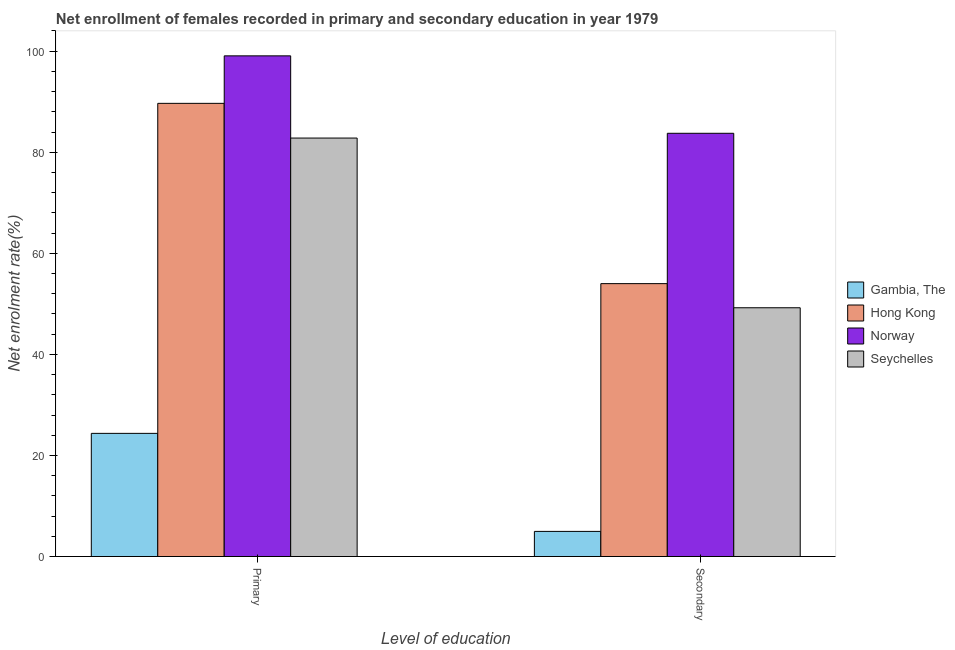How many groups of bars are there?
Make the answer very short. 2. Are the number of bars on each tick of the X-axis equal?
Offer a very short reply. Yes. How many bars are there on the 2nd tick from the left?
Provide a short and direct response. 4. What is the label of the 2nd group of bars from the left?
Offer a very short reply. Secondary. What is the enrollment rate in primary education in Hong Kong?
Keep it short and to the point. 89.68. Across all countries, what is the maximum enrollment rate in secondary education?
Offer a terse response. 83.75. Across all countries, what is the minimum enrollment rate in primary education?
Make the answer very short. 24.37. In which country was the enrollment rate in secondary education maximum?
Offer a very short reply. Norway. In which country was the enrollment rate in primary education minimum?
Offer a terse response. Gambia, The. What is the total enrollment rate in primary education in the graph?
Your answer should be very brief. 295.93. What is the difference between the enrollment rate in primary education in Hong Kong and that in Norway?
Offer a terse response. -9.4. What is the difference between the enrollment rate in secondary education in Hong Kong and the enrollment rate in primary education in Norway?
Provide a succinct answer. -45.07. What is the average enrollment rate in secondary education per country?
Provide a succinct answer. 47.99. What is the difference between the enrollment rate in primary education and enrollment rate in secondary education in Seychelles?
Your response must be concise. 33.58. What is the ratio of the enrollment rate in primary education in Norway to that in Seychelles?
Keep it short and to the point. 1.2. Is the enrollment rate in secondary education in Seychelles less than that in Norway?
Offer a terse response. Yes. In how many countries, is the enrollment rate in primary education greater than the average enrollment rate in primary education taken over all countries?
Your answer should be compact. 3. What does the 2nd bar from the left in Secondary represents?
Give a very brief answer. Hong Kong. What does the 3rd bar from the right in Secondary represents?
Provide a short and direct response. Hong Kong. Are the values on the major ticks of Y-axis written in scientific E-notation?
Provide a succinct answer. No. Where does the legend appear in the graph?
Give a very brief answer. Center right. How are the legend labels stacked?
Give a very brief answer. Vertical. What is the title of the graph?
Your response must be concise. Net enrollment of females recorded in primary and secondary education in year 1979. What is the label or title of the X-axis?
Ensure brevity in your answer.  Level of education. What is the label or title of the Y-axis?
Give a very brief answer. Net enrolment rate(%). What is the Net enrolment rate(%) of Gambia, The in Primary?
Your response must be concise. 24.37. What is the Net enrolment rate(%) in Hong Kong in Primary?
Provide a succinct answer. 89.68. What is the Net enrolment rate(%) of Norway in Primary?
Give a very brief answer. 99.07. What is the Net enrolment rate(%) in Seychelles in Primary?
Give a very brief answer. 82.81. What is the Net enrolment rate(%) of Gambia, The in Secondary?
Give a very brief answer. 4.97. What is the Net enrolment rate(%) of Hong Kong in Secondary?
Ensure brevity in your answer.  54. What is the Net enrolment rate(%) in Norway in Secondary?
Ensure brevity in your answer.  83.75. What is the Net enrolment rate(%) of Seychelles in Secondary?
Ensure brevity in your answer.  49.23. Across all Level of education, what is the maximum Net enrolment rate(%) in Gambia, The?
Make the answer very short. 24.37. Across all Level of education, what is the maximum Net enrolment rate(%) of Hong Kong?
Make the answer very short. 89.68. Across all Level of education, what is the maximum Net enrolment rate(%) in Norway?
Keep it short and to the point. 99.07. Across all Level of education, what is the maximum Net enrolment rate(%) of Seychelles?
Ensure brevity in your answer.  82.81. Across all Level of education, what is the minimum Net enrolment rate(%) in Gambia, The?
Offer a very short reply. 4.97. Across all Level of education, what is the minimum Net enrolment rate(%) in Hong Kong?
Offer a very short reply. 54. Across all Level of education, what is the minimum Net enrolment rate(%) of Norway?
Your answer should be very brief. 83.75. Across all Level of education, what is the minimum Net enrolment rate(%) of Seychelles?
Give a very brief answer. 49.23. What is the total Net enrolment rate(%) in Gambia, The in the graph?
Your answer should be very brief. 29.34. What is the total Net enrolment rate(%) in Hong Kong in the graph?
Make the answer very short. 143.68. What is the total Net enrolment rate(%) in Norway in the graph?
Your response must be concise. 182.82. What is the total Net enrolment rate(%) in Seychelles in the graph?
Your answer should be very brief. 132.04. What is the difference between the Net enrolment rate(%) in Gambia, The in Primary and that in Secondary?
Your response must be concise. 19.4. What is the difference between the Net enrolment rate(%) in Hong Kong in Primary and that in Secondary?
Offer a terse response. 35.68. What is the difference between the Net enrolment rate(%) of Norway in Primary and that in Secondary?
Give a very brief answer. 15.32. What is the difference between the Net enrolment rate(%) of Seychelles in Primary and that in Secondary?
Provide a short and direct response. 33.58. What is the difference between the Net enrolment rate(%) of Gambia, The in Primary and the Net enrolment rate(%) of Hong Kong in Secondary?
Provide a short and direct response. -29.63. What is the difference between the Net enrolment rate(%) of Gambia, The in Primary and the Net enrolment rate(%) of Norway in Secondary?
Offer a terse response. -59.38. What is the difference between the Net enrolment rate(%) of Gambia, The in Primary and the Net enrolment rate(%) of Seychelles in Secondary?
Give a very brief answer. -24.86. What is the difference between the Net enrolment rate(%) in Hong Kong in Primary and the Net enrolment rate(%) in Norway in Secondary?
Keep it short and to the point. 5.92. What is the difference between the Net enrolment rate(%) in Hong Kong in Primary and the Net enrolment rate(%) in Seychelles in Secondary?
Offer a terse response. 40.45. What is the difference between the Net enrolment rate(%) of Norway in Primary and the Net enrolment rate(%) of Seychelles in Secondary?
Offer a terse response. 49.85. What is the average Net enrolment rate(%) in Gambia, The per Level of education?
Offer a very short reply. 14.67. What is the average Net enrolment rate(%) in Hong Kong per Level of education?
Offer a very short reply. 71.84. What is the average Net enrolment rate(%) in Norway per Level of education?
Provide a short and direct response. 91.41. What is the average Net enrolment rate(%) of Seychelles per Level of education?
Offer a very short reply. 66.02. What is the difference between the Net enrolment rate(%) in Gambia, The and Net enrolment rate(%) in Hong Kong in Primary?
Ensure brevity in your answer.  -65.3. What is the difference between the Net enrolment rate(%) in Gambia, The and Net enrolment rate(%) in Norway in Primary?
Make the answer very short. -74.7. What is the difference between the Net enrolment rate(%) in Gambia, The and Net enrolment rate(%) in Seychelles in Primary?
Offer a very short reply. -58.44. What is the difference between the Net enrolment rate(%) in Hong Kong and Net enrolment rate(%) in Norway in Primary?
Ensure brevity in your answer.  -9.4. What is the difference between the Net enrolment rate(%) in Hong Kong and Net enrolment rate(%) in Seychelles in Primary?
Keep it short and to the point. 6.87. What is the difference between the Net enrolment rate(%) of Norway and Net enrolment rate(%) of Seychelles in Primary?
Your answer should be compact. 16.27. What is the difference between the Net enrolment rate(%) of Gambia, The and Net enrolment rate(%) of Hong Kong in Secondary?
Provide a short and direct response. -49.03. What is the difference between the Net enrolment rate(%) in Gambia, The and Net enrolment rate(%) in Norway in Secondary?
Keep it short and to the point. -78.78. What is the difference between the Net enrolment rate(%) of Gambia, The and Net enrolment rate(%) of Seychelles in Secondary?
Your answer should be compact. -44.25. What is the difference between the Net enrolment rate(%) of Hong Kong and Net enrolment rate(%) of Norway in Secondary?
Your response must be concise. -29.75. What is the difference between the Net enrolment rate(%) of Hong Kong and Net enrolment rate(%) of Seychelles in Secondary?
Offer a terse response. 4.77. What is the difference between the Net enrolment rate(%) in Norway and Net enrolment rate(%) in Seychelles in Secondary?
Ensure brevity in your answer.  34.52. What is the ratio of the Net enrolment rate(%) of Gambia, The in Primary to that in Secondary?
Ensure brevity in your answer.  4.9. What is the ratio of the Net enrolment rate(%) of Hong Kong in Primary to that in Secondary?
Your answer should be compact. 1.66. What is the ratio of the Net enrolment rate(%) in Norway in Primary to that in Secondary?
Provide a short and direct response. 1.18. What is the ratio of the Net enrolment rate(%) in Seychelles in Primary to that in Secondary?
Make the answer very short. 1.68. What is the difference between the highest and the second highest Net enrolment rate(%) of Gambia, The?
Offer a terse response. 19.4. What is the difference between the highest and the second highest Net enrolment rate(%) in Hong Kong?
Your answer should be very brief. 35.68. What is the difference between the highest and the second highest Net enrolment rate(%) of Norway?
Your answer should be very brief. 15.32. What is the difference between the highest and the second highest Net enrolment rate(%) in Seychelles?
Your answer should be compact. 33.58. What is the difference between the highest and the lowest Net enrolment rate(%) in Gambia, The?
Make the answer very short. 19.4. What is the difference between the highest and the lowest Net enrolment rate(%) of Hong Kong?
Ensure brevity in your answer.  35.68. What is the difference between the highest and the lowest Net enrolment rate(%) of Norway?
Ensure brevity in your answer.  15.32. What is the difference between the highest and the lowest Net enrolment rate(%) of Seychelles?
Offer a very short reply. 33.58. 